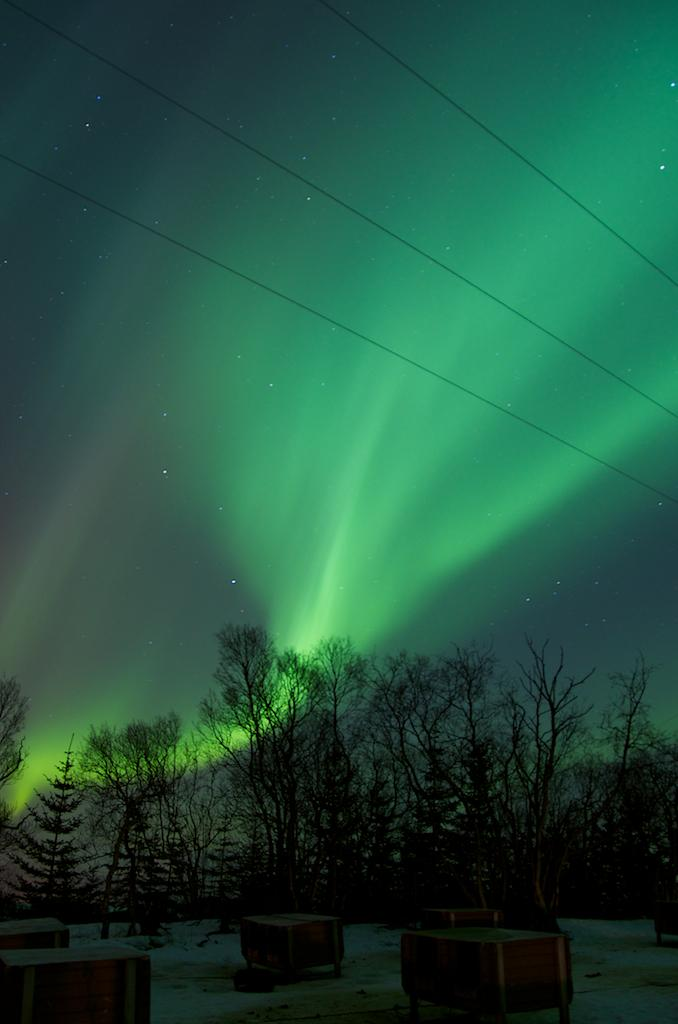What can be found at the bottom of the image? There are objects in the bottom of the image. What type of natural environment is visible in the image depicts? The image shows trees visible at the back, indicating a natural setting. What is visible at the top of the image? The sky is visible at the top of the image. What type of man-made structures are present in the image? There are wires in the image. What celestial objects can be seen in the image? There are stars visible in the image. What type of light is present in the image? There is a green light in the image. Can you tell me how many caves contribute to the growth of the trees in the image? There are no caves present in the image, and therefore their impact on the growth of the trees cannot be determined. What type of request is being made by the stars in the image? There are no requests being made by the stars in the image; they are simply celestial objects visible in the sky. 